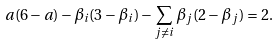<formula> <loc_0><loc_0><loc_500><loc_500>a ( 6 - a ) - \beta _ { i } ( 3 - \beta _ { i } ) - \sum _ { j \neq i } \beta _ { j } ( 2 - \beta _ { j } ) = 2 .</formula> 